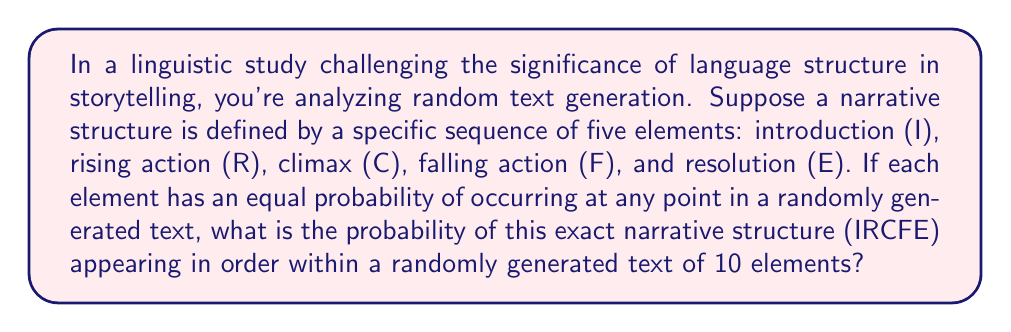Solve this math problem. Let's approach this step-by-step:

1) First, we need to consider that we're looking for a specific sequence (IRCFE) within a larger sequence of 10 elements.

2) The probability of each element occurring at any point is $\frac{1}{5}$, as there are 5 possible elements with equal probability.

3) For the specific sequence to occur, we need:
   - I in the first position
   - R in the second position
   - C in the third position
   - F in the fourth position
   - E in the fifth position

4) The probability of this exact sequence occurring is:

   $$P(\text{IRCFE}) = \frac{1}{5} \cdot \frac{1}{5} \cdot \frac{1}{5} \cdot \frac{1}{5} \cdot \frac{1}{5} = \left(\frac{1}{5}\right)^5 = \frac{1}{3125}$$

5) However, this sequence can start at any of the first 6 positions in the 10-element text (positions 1-6) to still fit within the 10 elements.

6) These 6 possible starting positions are mutually exclusive events, so we add their probabilities:

   $$P(\text{IRCFE in 10 elements}) = 6 \cdot \frac{1}{3125} = \frac{6}{3125} = \frac{48}{25000}$$

This probability represents the chance of this narrative structure occurring in the exact order within a 10-element random text, challenging the notion that language structure significantly affects storytelling by demonstrating the low probability of a specific structure emerging by chance.
Answer: $\frac{48}{25000}$ or $0.00192$ 